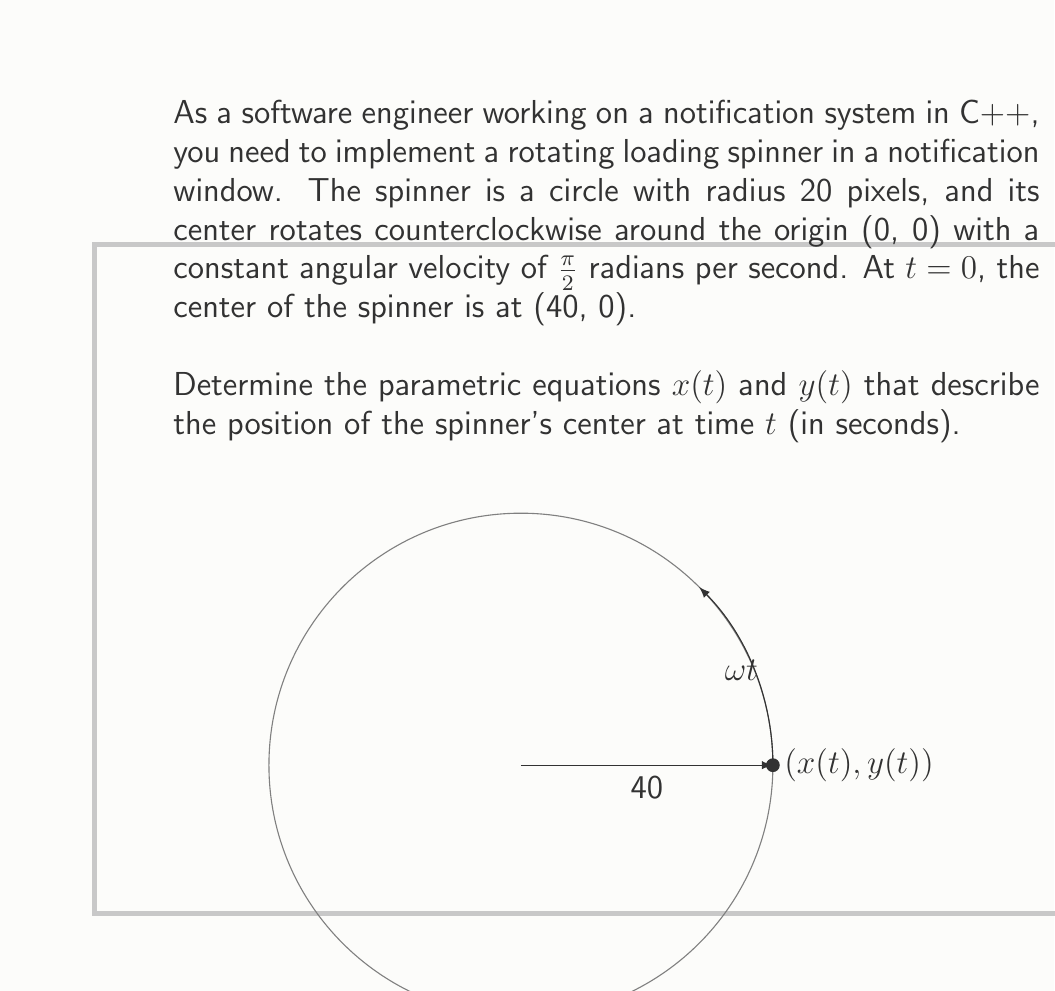Show me your answer to this math problem. Let's approach this step-by-step:

1) The spinner's center rotates in a circle with radius 40 pixels (since it starts at (40, 0)).

2) The angular velocity ω is π/2 radians per second.

3) At time t, the angle swept by the spinner's center is ωt = (π/2)t radians.

4) For a point rotating around the origin, we can use the general parametric equations:
   
   $x(t) = r \cos(\theta)$
   $y(t) = r \sin(\theta)$

   Where r is the radius and θ is the angle.

5) In our case:
   r = 40
   θ = ωt = (π/2)t

6) Substituting these into our general equations:

   $x(t) = 40 \cos((π/2)t)$
   $y(t) = 40 \sin((π/2)t)$

These equations give the (x, y) coordinates of the spinner's center at any time t.
Answer: $x(t) = 40 \cos((π/2)t)$, $y(t) = 40 \sin((π/2)t)$ 